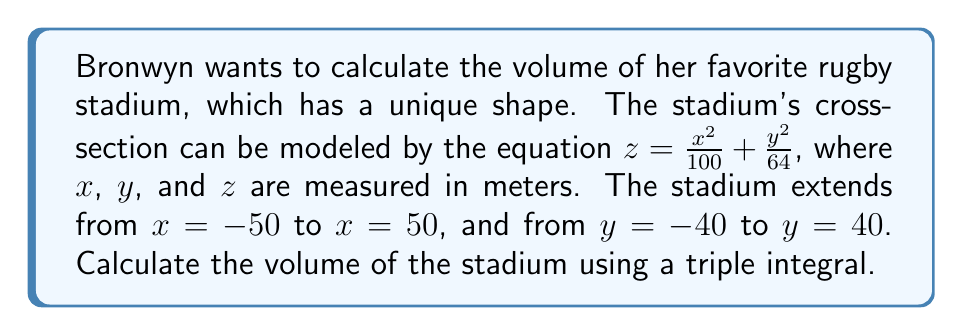Provide a solution to this math problem. To calculate the volume of the rugby stadium, we need to set up and evaluate a triple integral. Let's approach this step-by-step:

1) The volume is given by the triple integral:

   $$V = \iiint_V dV = \int_{-50}^{50} \int_{-40}^{40} \int_0^{z(x,y)} dz dy dx$$

2) The upper bound of the z-integral is given by the equation of the stadium's surface:

   $$z(x,y) = \frac{x^2}{100} + \frac{y^2}{64}$$

3) Let's set up the triple integral:

   $$V = \int_{-50}^{50} \int_{-40}^{40} \int_0^{\frac{x^2}{100} + \frac{y^2}{64}} dz dy dx$$

4) First, integrate with respect to z:

   $$V = \int_{-50}^{50} \int_{-40}^{40} \left[\frac{x^2}{100} + \frac{y^2}{64}\right] dy dx$$

5) Now, integrate with respect to y:

   $$V = \int_{-50}^{50} \left[y\left(\frac{x^2}{100} + \frac{y^2}{192}\right)\right]_{-40}^{40} dx$$
   
   $$= \int_{-50}^{50} \left[40\left(\frac{x^2}{100} + \frac{1600}{192}\right) + 40\left(\frac{x^2}{100} + \frac{1600}{192}\right)\right] dx$$
   
   $$= \int_{-50}^{50} \left[80\frac{x^2}{100} + 80\frac{1600}{192}\right] dx$$

6) Finally, integrate with respect to x:

   $$V = \left[\frac{80x^3}{300} + 80\frac{1600}{192}x\right]_{-50}^{50}$$
   
   $$= \left[\frac{80(50^3)}{300} + 80\frac{1600}{192}(50)\right] - \left[\frac{80(-50^3)}{300} + 80\frac{1600}{192}(-50)\right]$$
   
   $$= \frac{80(125000)}{300} + \frac{6666666.67}{3} = 33333.33 + 2222222.22 = 2255555.55$$

Therefore, the volume of the stadium is approximately 2,255,555.55 cubic meters.
Answer: 2,255,555.55 m³ 